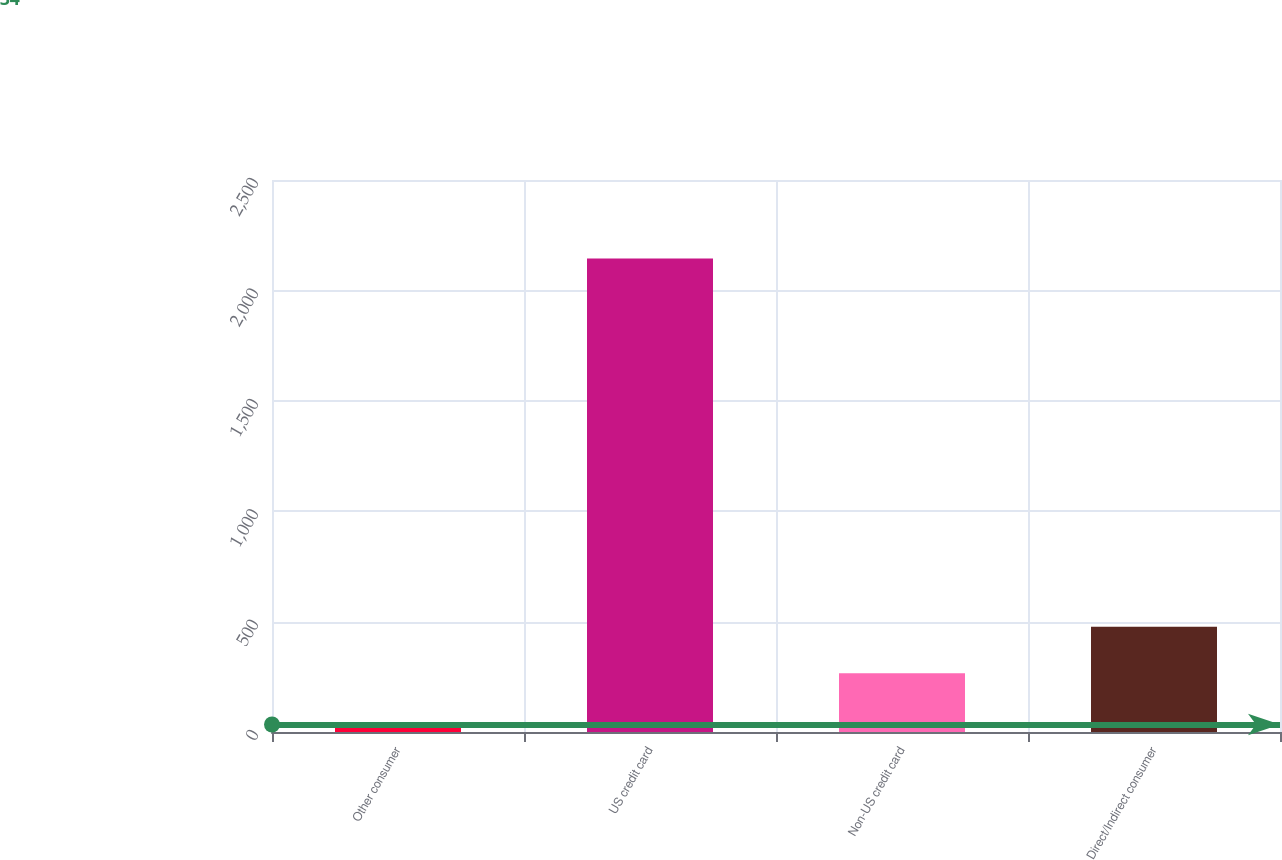Convert chart. <chart><loc_0><loc_0><loc_500><loc_500><bar_chart><fcel>Other consumer<fcel>US credit card<fcel>Non-US credit card<fcel>Direct/Indirect consumer<nl><fcel>34<fcel>2144<fcel>266<fcel>477<nl></chart> 